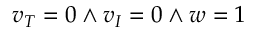Convert formula to latex. <formula><loc_0><loc_0><loc_500><loc_500>v _ { T } = 0 \land v _ { I } = 0 \land w = 1</formula> 